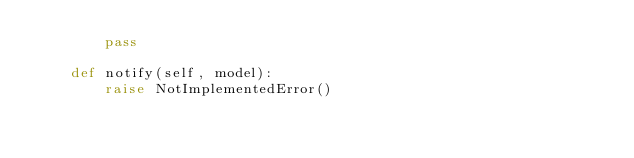Convert code to text. <code><loc_0><loc_0><loc_500><loc_500><_Python_>		pass

	def notify(self, model):
		raise NotImplementedError()</code> 